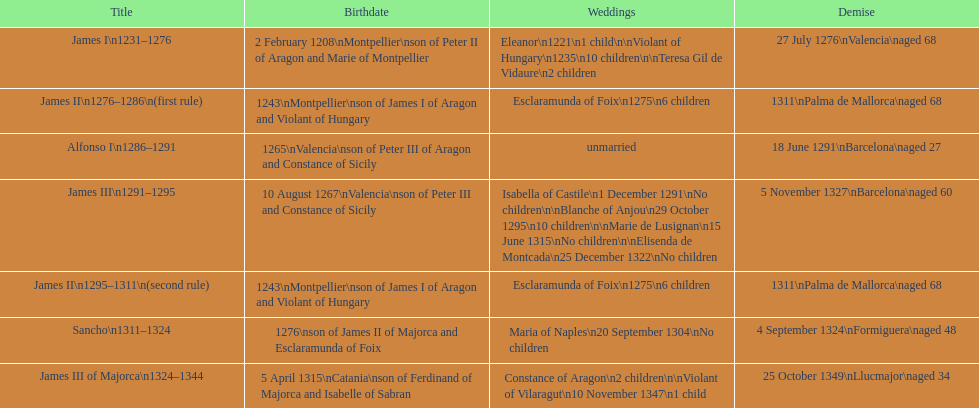How many total marriages did james i have? 3. Write the full table. {'header': ['Title', 'Birthdate', 'Weddings', 'Demise'], 'rows': [['James I\\n1231–1276', '2 February 1208\\nMontpellier\\nson of Peter II of Aragon and Marie of Montpellier', 'Eleanor\\n1221\\n1 child\\n\\nViolant of Hungary\\n1235\\n10 children\\n\\nTeresa Gil de Vidaure\\n2 children', '27 July 1276\\nValencia\\naged 68'], ['James II\\n1276–1286\\n(first rule)', '1243\\nMontpellier\\nson of James I of Aragon and Violant of Hungary', 'Esclaramunda of Foix\\n1275\\n6 children', '1311\\nPalma de Mallorca\\naged 68'], ['Alfonso I\\n1286–1291', '1265\\nValencia\\nson of Peter III of Aragon and Constance of Sicily', 'unmarried', '18 June 1291\\nBarcelona\\naged 27'], ['James III\\n1291–1295', '10 August 1267\\nValencia\\nson of Peter III and Constance of Sicily', 'Isabella of Castile\\n1 December 1291\\nNo children\\n\\nBlanche of Anjou\\n29 October 1295\\n10 children\\n\\nMarie de Lusignan\\n15 June 1315\\nNo children\\n\\nElisenda de Montcada\\n25 December 1322\\nNo children', '5 November 1327\\nBarcelona\\naged 60'], ['James II\\n1295–1311\\n(second rule)', '1243\\nMontpellier\\nson of James I of Aragon and Violant of Hungary', 'Esclaramunda of Foix\\n1275\\n6 children', '1311\\nPalma de Mallorca\\naged 68'], ['Sancho\\n1311–1324', '1276\\nson of James II of Majorca and Esclaramunda of Foix', 'Maria of Naples\\n20 September 1304\\nNo children', '4 September 1324\\nFormiguera\\naged 48'], ['James III of Majorca\\n1324–1344', '5 April 1315\\nCatania\\nson of Ferdinand of Majorca and Isabelle of Sabran', 'Constance of Aragon\\n2 children\\n\\nViolant of Vilaragut\\n10 November 1347\\n1 child', '25 October 1349\\nLlucmajor\\naged 34']]} 